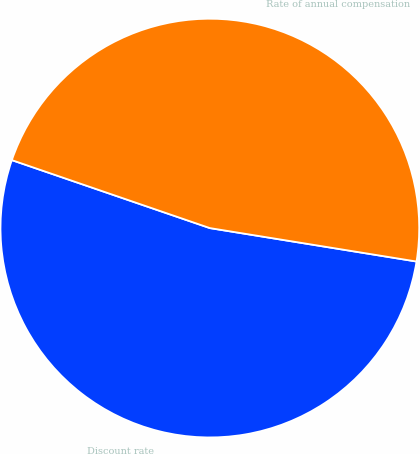Convert chart to OTSL. <chart><loc_0><loc_0><loc_500><loc_500><pie_chart><fcel>Discount rate<fcel>Rate of annual compensation<nl><fcel>52.71%<fcel>47.29%<nl></chart> 